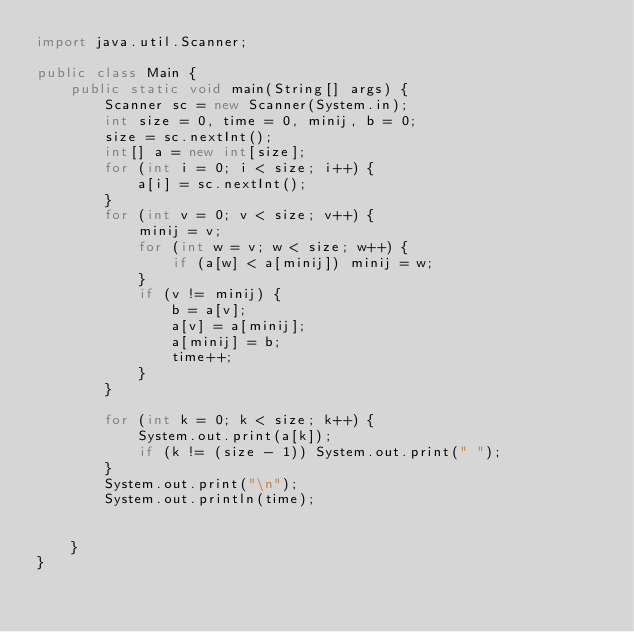Convert code to text. <code><loc_0><loc_0><loc_500><loc_500><_Java_>import java.util.Scanner;

public class Main {
    public static void main(String[] args) {
        Scanner sc = new Scanner(System.in);
        int size = 0, time = 0, minij, b = 0;
        size = sc.nextInt();
        int[] a = new int[size];
        for (int i = 0; i < size; i++) {
            a[i] = sc.nextInt();
        }
        for (int v = 0; v < size; v++) {
            minij = v;
            for (int w = v; w < size; w++) {
                if (a[w] < a[minij]) minij = w;
            }
            if (v != minij) {
                b = a[v];
                a[v] = a[minij];
                a[minij] = b;
                time++;
            }
        }

        for (int k = 0; k < size; k++) {
            System.out.print(a[k]);
            if (k != (size - 1)) System.out.print(" ");
        }
        System.out.print("\n");
        System.out.println(time);


    }
}

</code> 